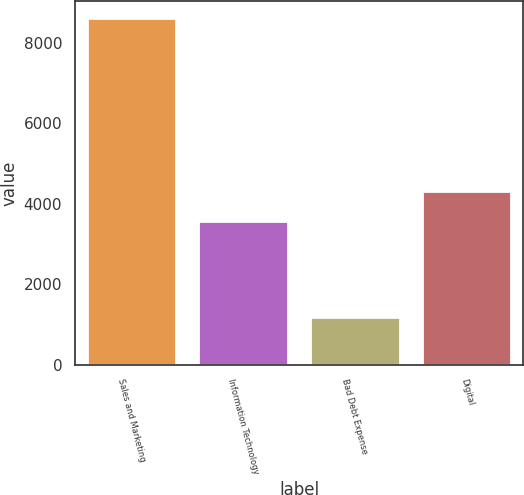<chart> <loc_0><loc_0><loc_500><loc_500><bar_chart><fcel>Sales and Marketing<fcel>Information Technology<fcel>Bad Debt Expense<fcel>Digital<nl><fcel>8618<fcel>3573<fcel>1199<fcel>4314.9<nl></chart> 